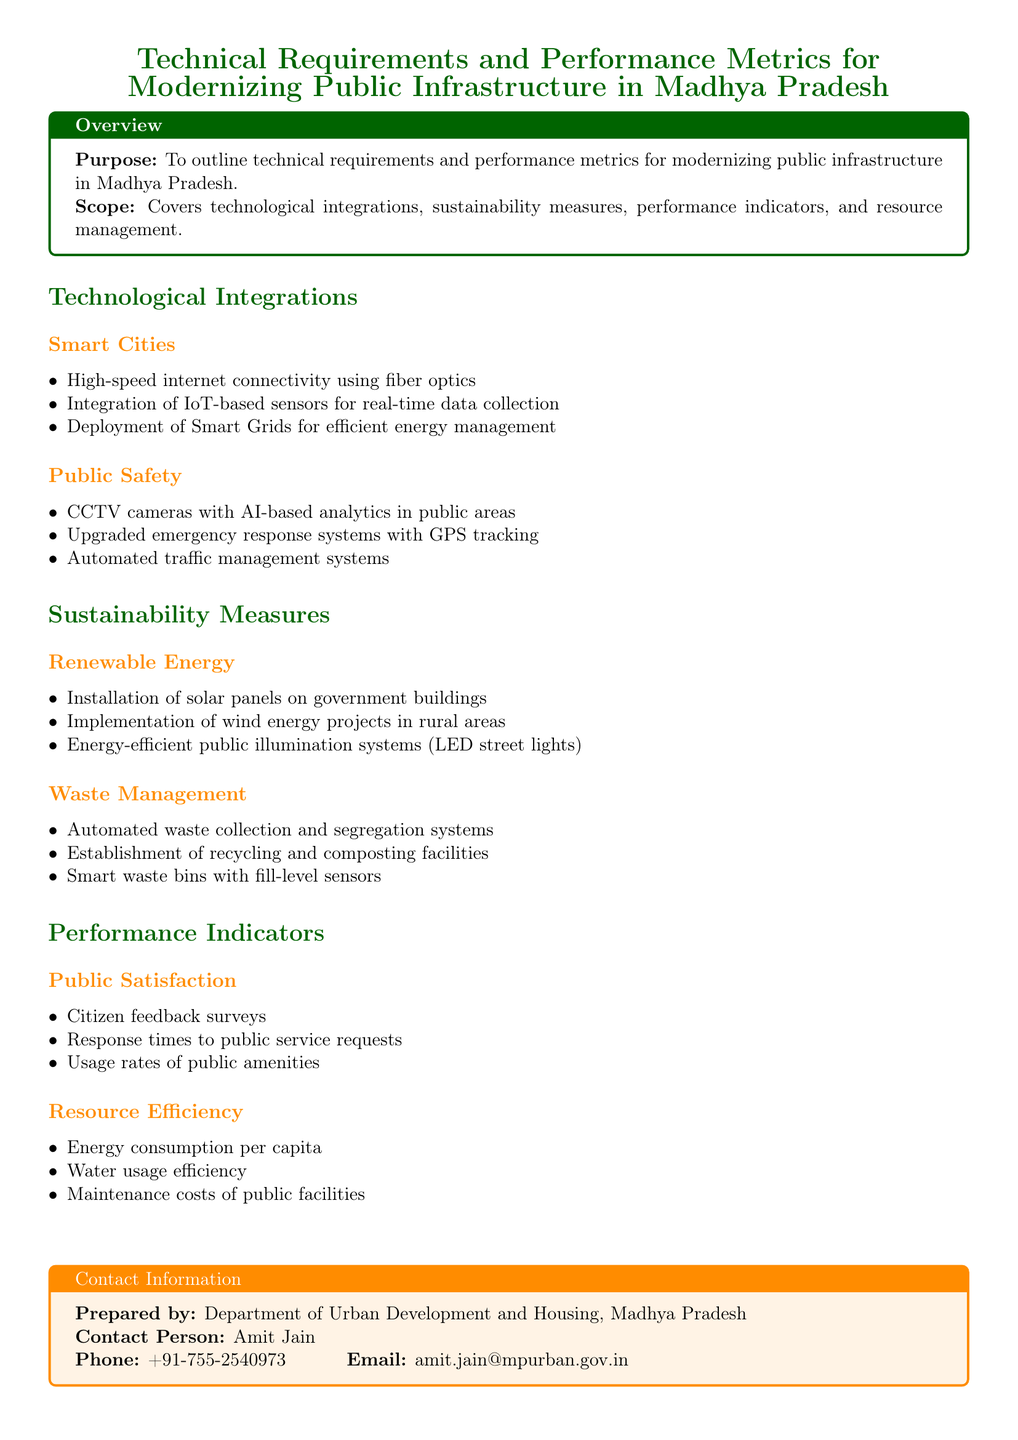What is the purpose of the document? The purpose is outlined in the "Overview" section, which states that it is to outline technical requirements and performance metrics for modernizing public infrastructure in Madhya Pradesh.
Answer: To outline technical requirements and performance metrics What technology is used for public safety? The public safety section describes technologies used, including CCTV cameras with AI-based analytics.
Answer: CCTV cameras with AI-based analytics Which renewable energy project is mentioned for rural areas? The renewable energy section states an implementation of wind energy projects specifically in rural areas.
Answer: Wind energy projects What is one performance indicator for resource efficiency? The performance indicators section lists resource efficiency metrics, with energy consumption per capita as one example.
Answer: Energy consumption per capita Who prepared the document? The "Contact Information" section specifies that the document was prepared by the Department of Urban Development and Housing, Madhya Pradesh.
Answer: Department of Urban Development and Housing, Madhya Pradesh What type of waste management system is mentioned? The waste management section includes mention of automated waste collection and segregation systems.
Answer: Automated waste collection and segregation systems What is one measure included for public satisfaction? The public satisfaction section includes citizen feedback surveys as a measure.
Answer: Citizen feedback surveys What is highlighted as part of technological integrations in smart cities? The integration section states that high-speed internet connectivity using fiber optics is a highlighted technology.
Answer: High-speed internet connectivity using fiber optics 